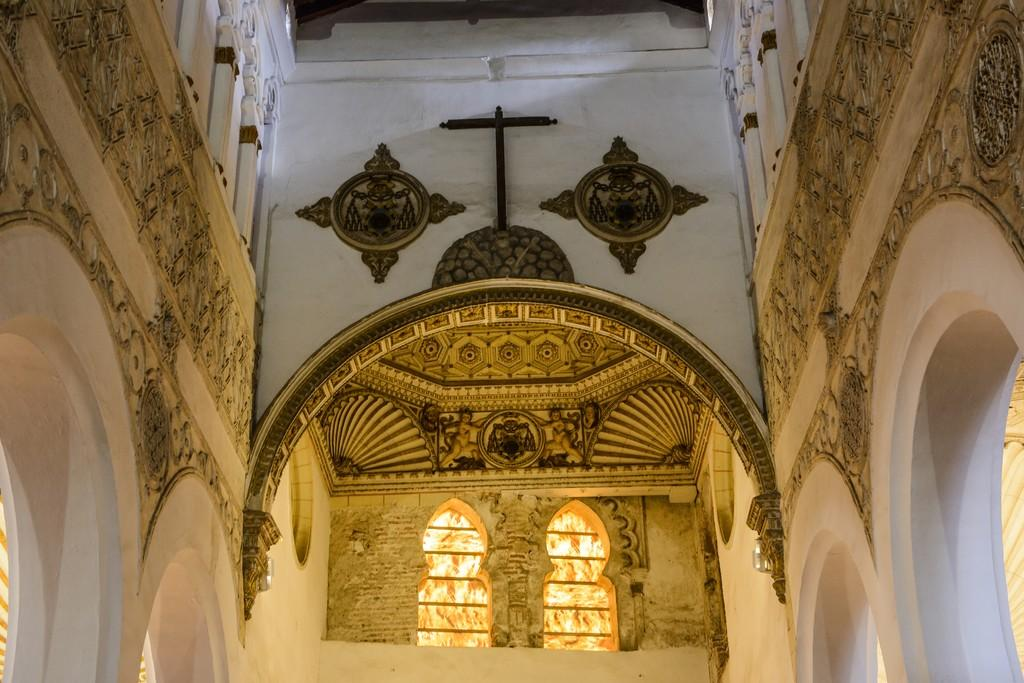What part of a building is shown in the image? The image shows the inner part of a building. What can be seen on the wall in the image? There are grey color objects on the wall. Where are the windows located in the image? The windows are at the bottom of the image. What is featured on the wall besides the grey objects? There is art on the wall. Can you see a girl interacting with the leaves in the image? There is no girl or leaves present in the image. What type of waste is visible on the floor in the image? There is no waste visible on the floor in the image. 